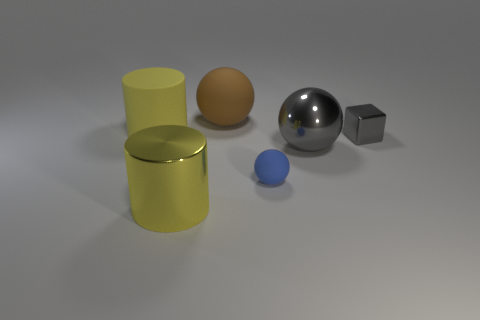Add 2 gray metallic objects. How many objects exist? 8 Subtract all cylinders. How many objects are left? 4 Subtract all small balls. Subtract all small red things. How many objects are left? 5 Add 3 tiny blue spheres. How many tiny blue spheres are left? 4 Add 3 yellow things. How many yellow things exist? 5 Subtract 1 yellow cylinders. How many objects are left? 5 